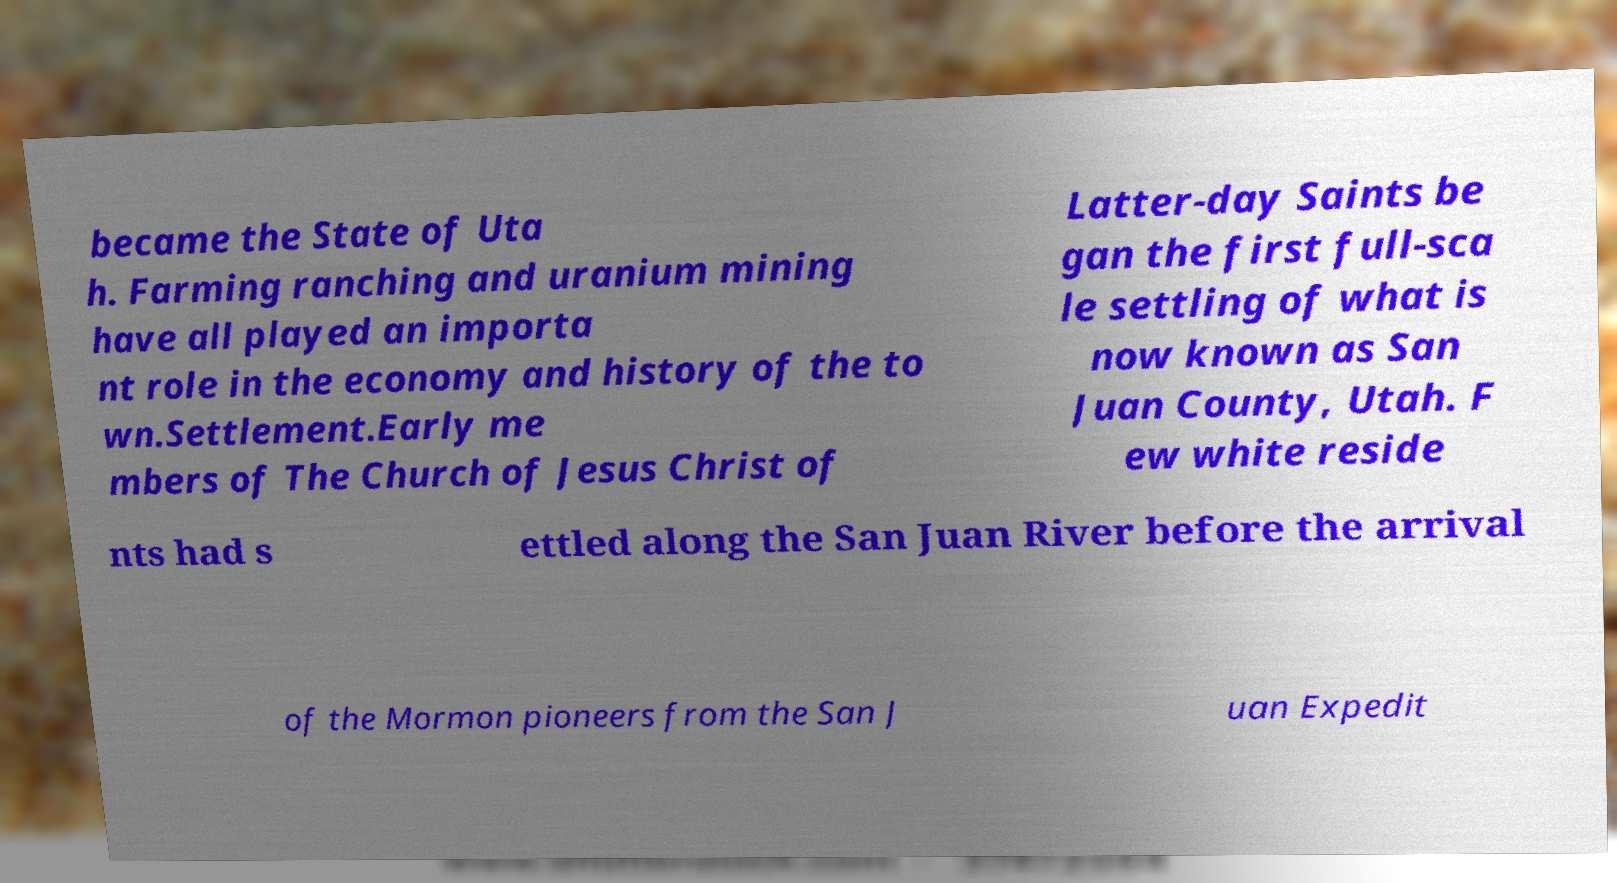Could you assist in decoding the text presented in this image and type it out clearly? became the State of Uta h. Farming ranching and uranium mining have all played an importa nt role in the economy and history of the to wn.Settlement.Early me mbers of The Church of Jesus Christ of Latter-day Saints be gan the first full-sca le settling of what is now known as San Juan County, Utah. F ew white reside nts had s ettled along the San Juan River before the arrival of the Mormon pioneers from the San J uan Expedit 